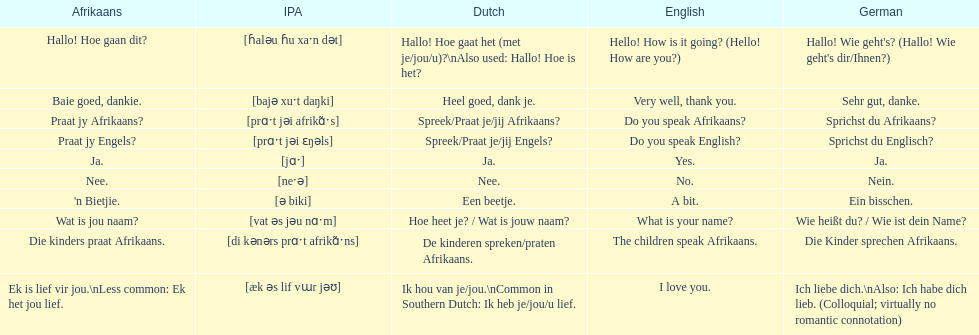What is the word for 'yes' in afrikaans? Ja. 